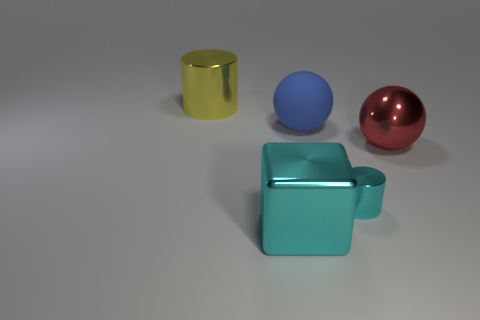Are there any other things that have the same size as the cyan shiny cylinder?
Your answer should be compact. No. There is a small cylinder that is the same color as the large cube; what material is it?
Offer a very short reply. Metal. Is there anything else that is made of the same material as the blue object?
Provide a short and direct response. No. Are there any other cyan objects that have the same shape as the small metallic object?
Your answer should be compact. No. Does the small object have the same color as the big cube?
Provide a succinct answer. Yes. What material is the thing right of the metallic cylinder that is in front of the big red ball?
Offer a very short reply. Metal. What is the size of the cyan cylinder?
Provide a short and direct response. Small. There is a yellow cylinder that is the same material as the big cyan object; what is its size?
Keep it short and to the point. Large. There is a cylinder that is to the left of the cyan metal block; is it the same size as the rubber sphere?
Provide a succinct answer. Yes. What shape is the large cyan shiny thing that is in front of the cyan shiny thing on the right side of the big sphere that is to the left of the red object?
Your response must be concise. Cube. 